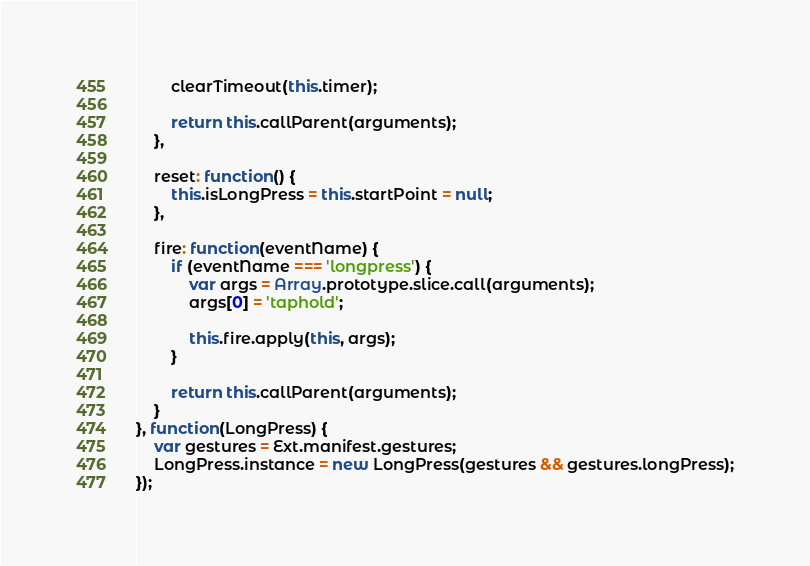<code> <loc_0><loc_0><loc_500><loc_500><_JavaScript_>        clearTimeout(this.timer);

        return this.callParent(arguments);
    },

    reset: function() {
        this.isLongPress = this.startPoint = null;
    },

    fire: function(eventName) {
        if (eventName === 'longpress') {
            var args = Array.prototype.slice.call(arguments);
            args[0] = 'taphold';

            this.fire.apply(this, args);
        }

        return this.callParent(arguments);
    }
}, function(LongPress) {
    var gestures = Ext.manifest.gestures;
    LongPress.instance = new LongPress(gestures && gestures.longPress);
});
</code> 